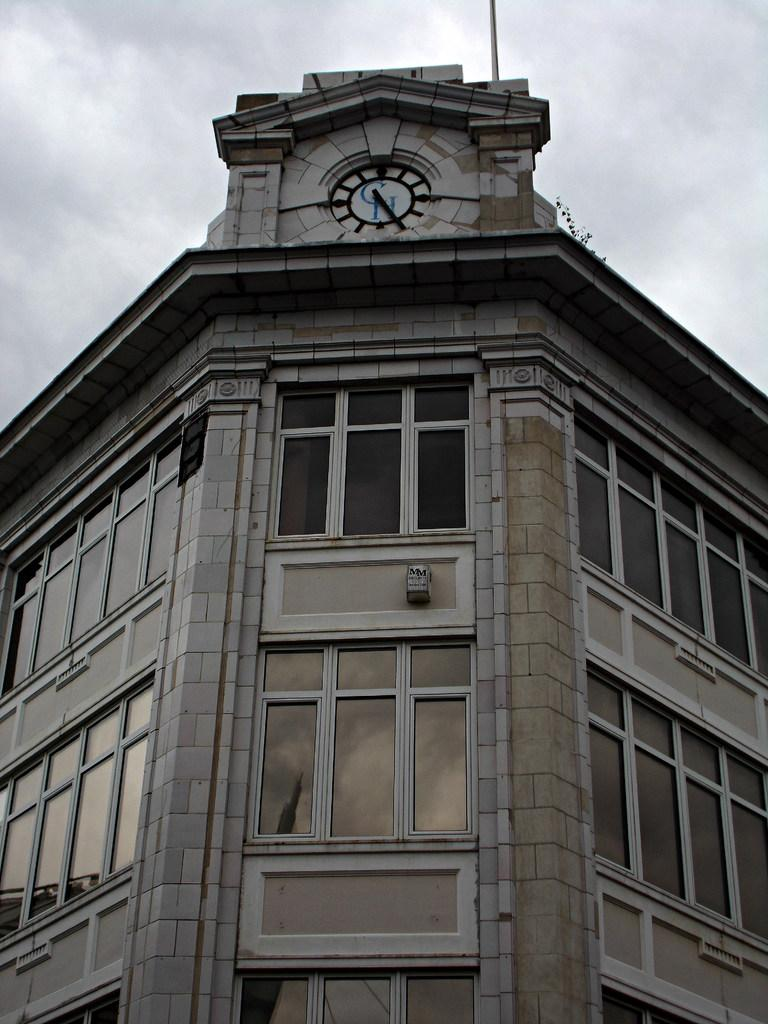What type of structure is visible in the image? There is a building in the image. What features can be seen on the building? The building has windows and a clock. What else is present in the image besides the building? There is a pole in the image. What can be seen in the background of the image? The sky is visible in the background of the image, and clouds are present. What type of punishment is being administered in the image? There is no punishment being administered in the image; it features a building with windows, a clock, a pole, and a sky with clouds. How many tents are visible in the image? There are no tents present in the image. 